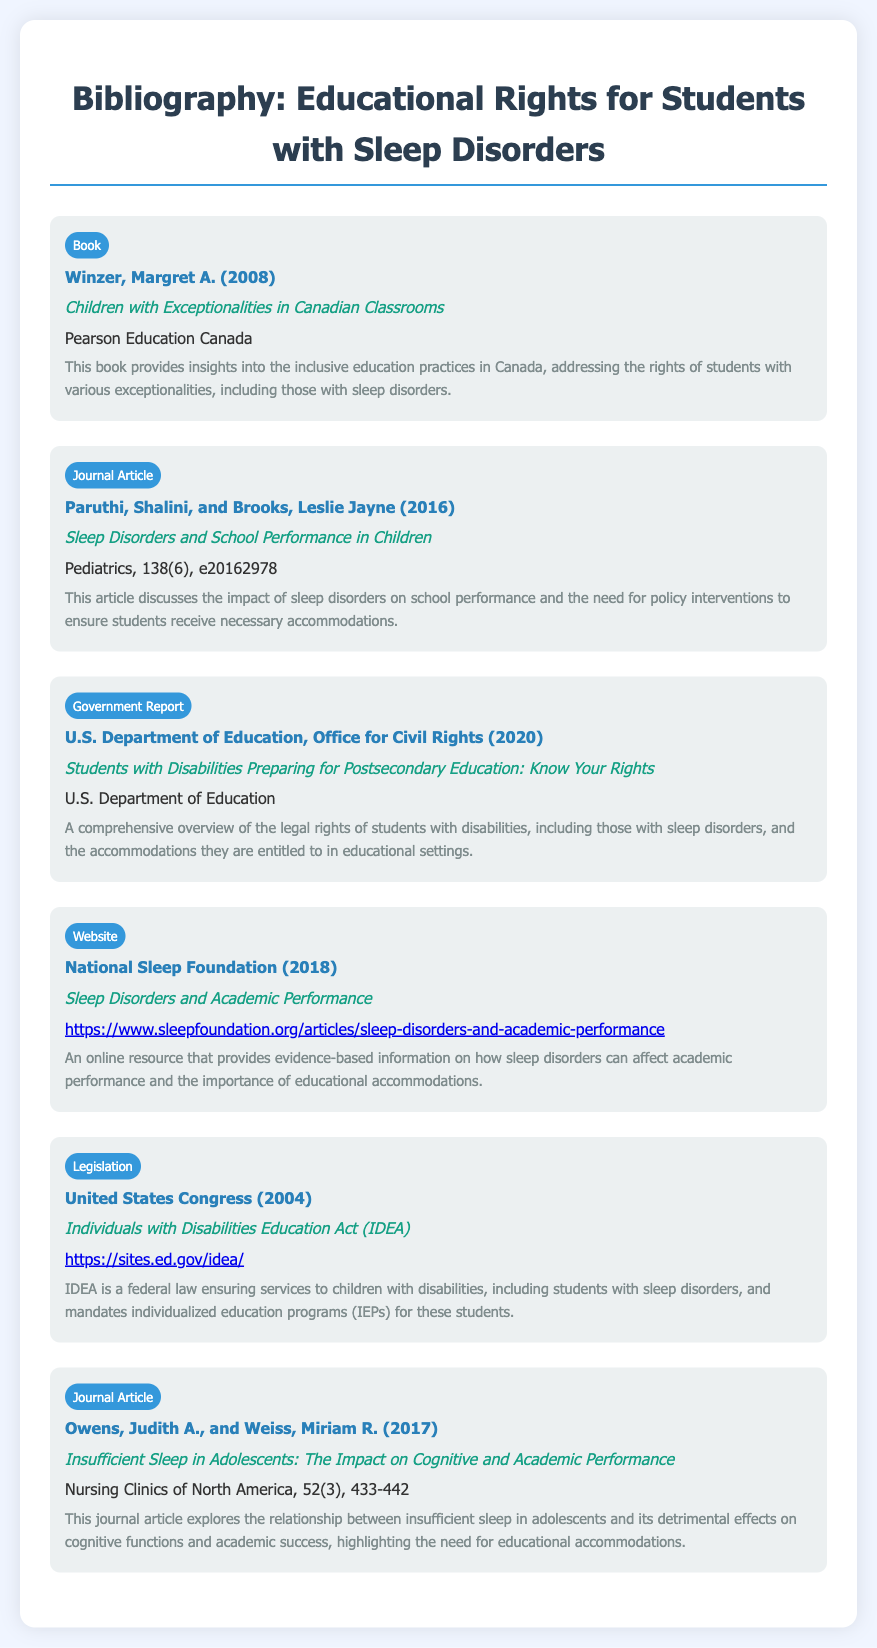what is the title of the book by Margret A. Winzer? The title of the book is listed in the document under the entry for the author, which is "Children with Exceptionalities in Canadian Classrooms."
Answer: Children with Exceptionalities in Canadian Classrooms who are the authors of the journal article titled "Sleep Disorders and School Performance in Children"? The authors are identified in the journal article entry, which lists "Paruthi, Shalini, and Brooks, Leslie Jayne."
Answer: Paruthi, Shalini, and Brooks, Leslie Jayne what year was the Individuals with Disabilities Education Act enacted? The document indicates the year in the legislation entry, which is 2004.
Answer: 2004 which organization published the report titled "Students with Disabilities Preparing for Postsecondary Education: Know Your Rights"? The organization is noted in the government report entry as the "U.S. Department of Education, Office for Civil Rights."
Answer: U.S. Department of Education, Office for Civil Rights how many journal articles are listed in the bibliography? The number of journal articles can be counted from the entries labeled "Journal Article," which appear twice in the document.
Answer: 2 what is the primary focus of the resource from the National Sleep Foundation? The focus is described in the document as providing evidence-based information on how sleep disorders can affect academic performance.
Answer: Sleep disorders and academic performance what type of document is the entry authored by the United States Congress? The entry specifically identifies the type of document as "Legislation."
Answer: Legislation which publication details the impact of insufficient sleep on cognitive performance? This information can be found in the description of the journal article by Owens and Weiss, which discusses insufficient sleep and its effects.
Answer: Insufficient Sleep in Adolescents: The Impact on Cognitive and Academic Performance 